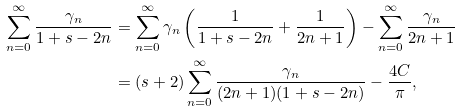<formula> <loc_0><loc_0><loc_500><loc_500>\sum _ { n = 0 } ^ { \infty } { \frac { \gamma _ { n } } { 1 + s - 2 n } } & = \sum _ { n = 0 } ^ { \infty } { \gamma _ { n } \left ( \frac { 1 } { 1 + s - 2 n } + \frac { 1 } { 2 n + 1 } \right ) } - \sum _ { n = 0 } ^ { \infty } { \frac { \gamma _ { n } } { 2 n + 1 } } \\ & = ( s + 2 ) \sum _ { n = 0 } ^ { \infty } { \frac { \gamma _ { n } } { ( 2 n + 1 ) ( 1 + s - 2 n ) } } - \frac { 4 C } { \pi } ,</formula> 